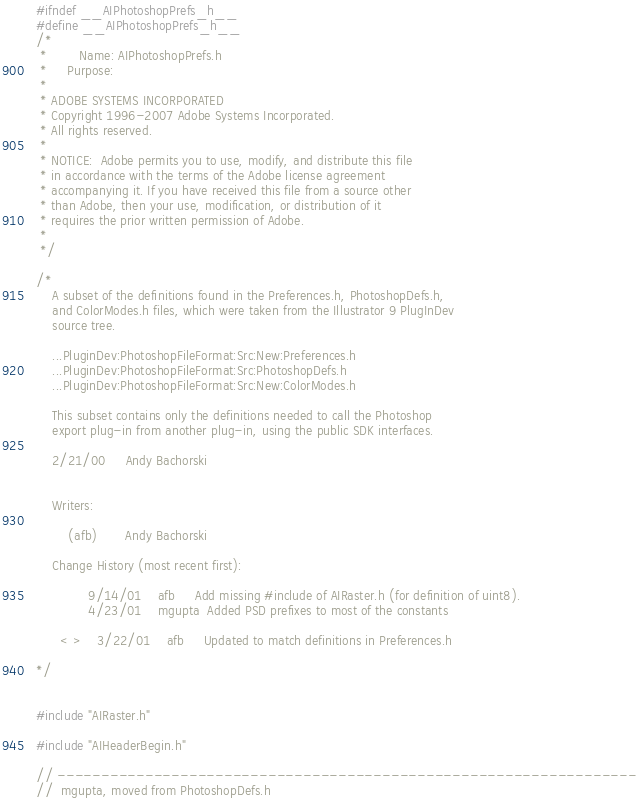<code> <loc_0><loc_0><loc_500><loc_500><_C_>#ifndef __AIPhotoshopPrefs_h__
#define __AIPhotoshopPrefs_h__
/*
 *        Name:	AIPhotoshopPrefs.h
 *     Purpose:	
 *
 * ADOBE SYSTEMS INCORPORATED
 * Copyright 1996-2007 Adobe Systems Incorporated.
 * All rights reserved.
 *
 * NOTICE:  Adobe permits you to use, modify, and distribute this file 
 * in accordance with the terms of the Adobe license agreement 
 * accompanying it. If you have received this file from a source other 
 * than Adobe, then your use, modification, or distribution of it 
 * requires the prior written permission of Adobe.
 *
 */

/*
	A subset of the definitions found in the Preferences.h, PhotoshopDefs.h,
	and ColorModes.h files, which were taken from the Illustrator 9 PlugInDev 
	source tree.
	
	...PluginDev:PhotoshopFileFormat:Src:New:Preferences.h
	...PluginDev:PhotoshopFileFormat:Src:PhotoshopDefs.h
	...PluginDev:PhotoshopFileFormat:Src:New:ColorModes.h
	
	This subset contains only the definitions needed to call the Photoshop
	export plug-in from another plug-in, using the public SDK interfaces.
	
	2/21/00		Andy Bachorski
	
	
	Writers:

		(afb)		Andy Bachorski

	Change History (most recent first):
			 
			 9/14/01	afb		Add missing #include of AIRaster.h (for definition of uint8).
			 4/23/01	mgupta	Added PSD prefixes to most of the constants

	  < >	 3/22/01	afb		Updated to match definitions in Preferences.h
	  
*/


#include "AIRaster.h"

#include "AIHeaderBegin.h"

// ------------------------------------------------------------------
//	mgupta, moved from PhotoshopDefs.h	</code> 